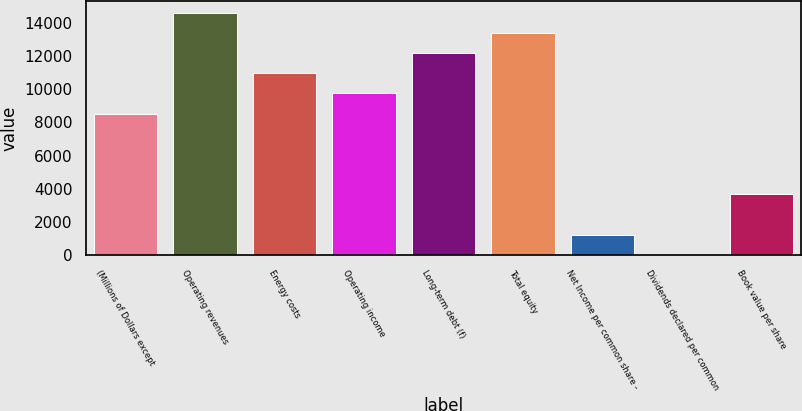Convert chart to OTSL. <chart><loc_0><loc_0><loc_500><loc_500><bar_chart><fcel>(Millions of Dollars except<fcel>Operating revenues<fcel>Energy costs<fcel>Operating income<fcel>Long-term debt (f)<fcel>Total equity<fcel>Net Income per common share -<fcel>Dividends declared per common<fcel>Book value per share<nl><fcel>8532.34<fcel>14625.1<fcel>10969.5<fcel>9750.9<fcel>12188<fcel>13406.6<fcel>1220.98<fcel>2.42<fcel>3658.1<nl></chart> 